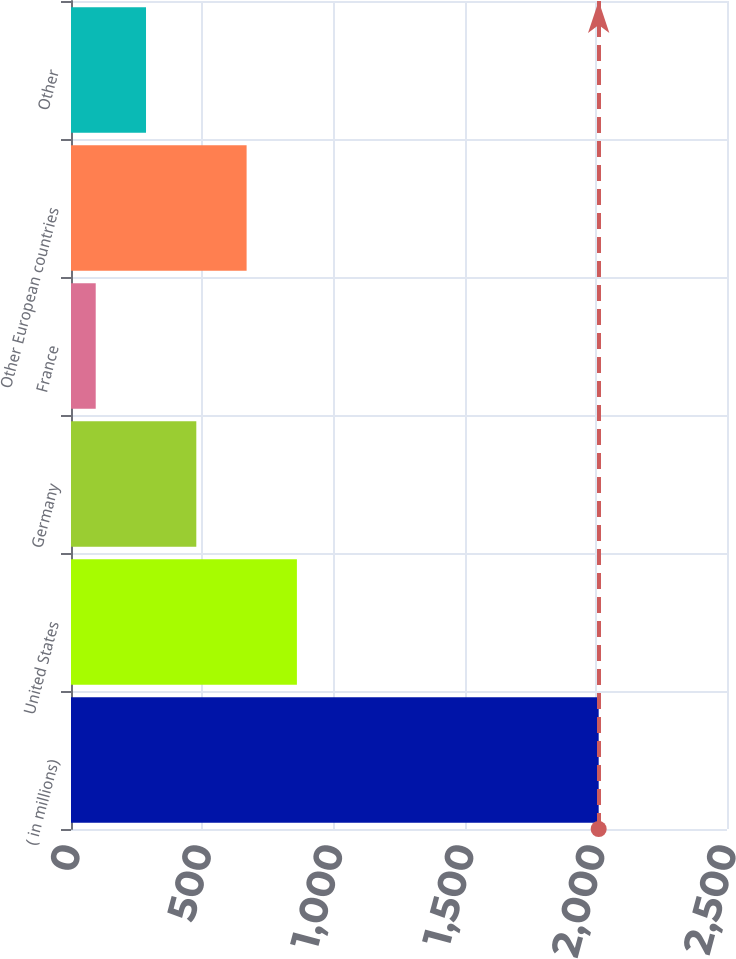Convert chart. <chart><loc_0><loc_0><loc_500><loc_500><bar_chart><fcel>( in millions)<fcel>United States<fcel>Germany<fcel>France<fcel>Other European countries<fcel>Other<nl><fcel>2011<fcel>860.92<fcel>477.56<fcel>94.2<fcel>669.24<fcel>285.88<nl></chart> 